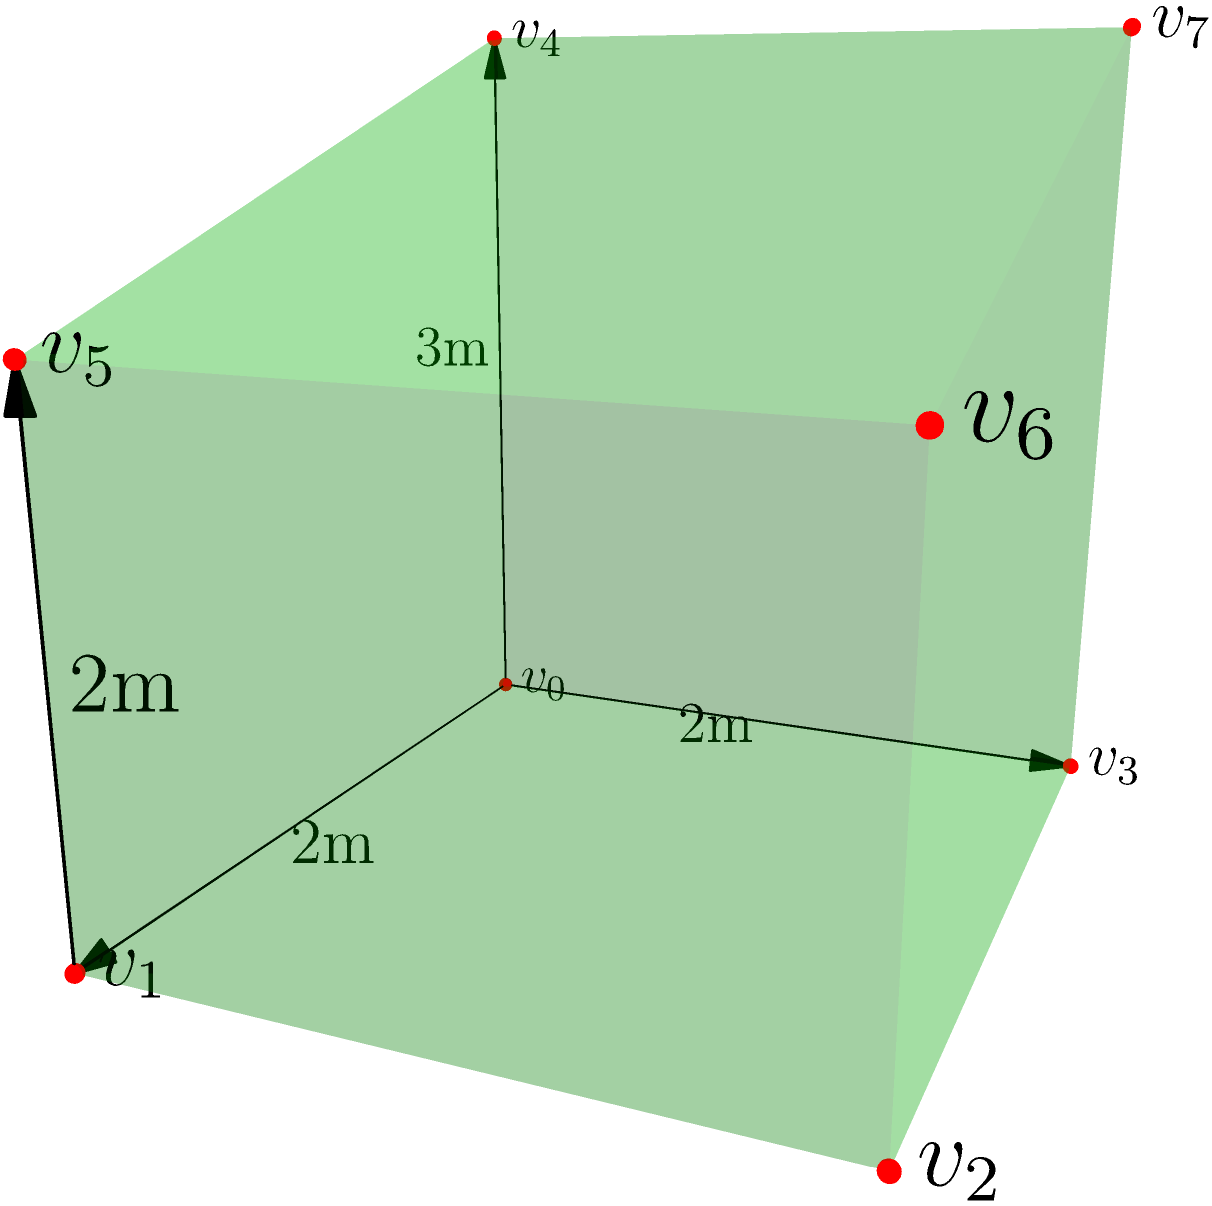As part of a green building design project, you're tasked with calculating the volume of an irregular polyhedron representing a sustainable structure. The polyhedron has a rectangular base of 2m by 2m. The front face rises vertically to a height of 3m, while the back face rises to 2m, creating a sloped roof. Calculate the volume of this structure in cubic meters. To calculate the volume of this irregular polyhedron, we can break it down into simpler geometric shapes:

1. First, we have a rectangular prism as the base:
   Volume of base = length × width × height
   $V_{base} = 2m \times 2m \times 2m = 8m^3$

2. On top of this, we have a triangular prism that forms the sloped roof:
   - The base of this triangular prism is a rectangle: 2m × 2m
   - The height of the triangle is the difference between the front and back heights: 3m - 2m = 1m
   
   Volume of triangular prism = $\frac{1}{2}$ × base area × length
   $V_{roof} = \frac{1}{2} \times 2m \times 1m \times 2m = 2m^3$

3. The total volume is the sum of these two parts:
   $V_{total} = V_{base} + V_{roof} = 8m^3 + 2m^3 = 10m^3$

Therefore, the volume of the irregular polyhedron is 10 cubic meters.
Answer: $10m^3$ 